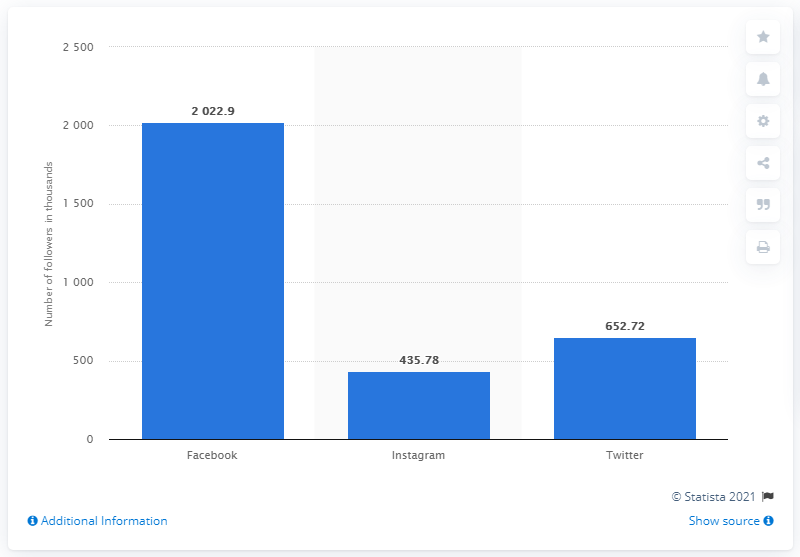List a handful of essential elements in this visual. The sum of Instagram and Twitter is 1088.5. Instagram has the least followers among all platforms. 